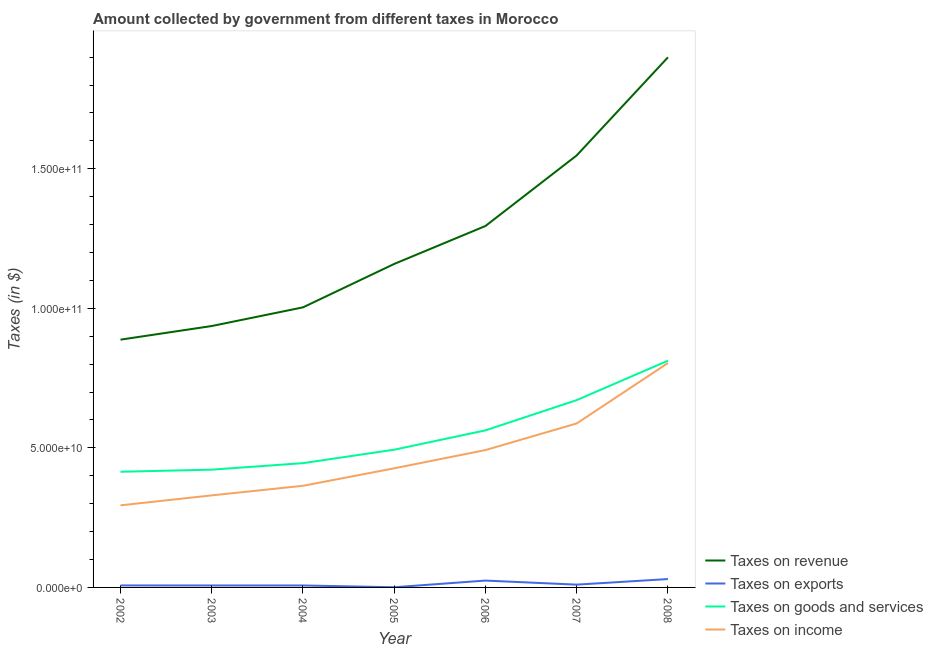Does the line corresponding to amount collected as tax on income intersect with the line corresponding to amount collected as tax on goods?
Keep it short and to the point. No. What is the amount collected as tax on revenue in 2007?
Ensure brevity in your answer.  1.55e+11. Across all years, what is the maximum amount collected as tax on goods?
Give a very brief answer. 8.12e+1. Across all years, what is the minimum amount collected as tax on income?
Offer a very short reply. 2.94e+1. What is the total amount collected as tax on goods in the graph?
Offer a terse response. 3.82e+11. What is the difference between the amount collected as tax on income in 2004 and that in 2007?
Provide a short and direct response. -2.23e+1. What is the difference between the amount collected as tax on income in 2002 and the amount collected as tax on exports in 2007?
Provide a succinct answer. 2.84e+1. What is the average amount collected as tax on goods per year?
Keep it short and to the point. 5.46e+1. In the year 2007, what is the difference between the amount collected as tax on exports and amount collected as tax on goods?
Keep it short and to the point. -6.61e+1. In how many years, is the amount collected as tax on revenue greater than 90000000000 $?
Offer a terse response. 6. What is the ratio of the amount collected as tax on income in 2003 to that in 2006?
Your answer should be very brief. 0.67. Is the amount collected as tax on revenue in 2005 less than that in 2008?
Keep it short and to the point. Yes. What is the difference between the highest and the second highest amount collected as tax on revenue?
Your answer should be very brief. 3.51e+1. What is the difference between the highest and the lowest amount collected as tax on exports?
Your answer should be very brief. 2.94e+09. In how many years, is the amount collected as tax on income greater than the average amount collected as tax on income taken over all years?
Offer a terse response. 3. Is it the case that in every year, the sum of the amount collected as tax on revenue and amount collected as tax on exports is greater than the amount collected as tax on goods?
Keep it short and to the point. Yes. Does the amount collected as tax on revenue monotonically increase over the years?
Offer a terse response. Yes. Is the amount collected as tax on exports strictly greater than the amount collected as tax on goods over the years?
Offer a terse response. No. How many years are there in the graph?
Keep it short and to the point. 7. Does the graph contain any zero values?
Keep it short and to the point. No. Does the graph contain grids?
Keep it short and to the point. No. Where does the legend appear in the graph?
Offer a very short reply. Bottom right. How many legend labels are there?
Ensure brevity in your answer.  4. What is the title of the graph?
Provide a short and direct response. Amount collected by government from different taxes in Morocco. What is the label or title of the X-axis?
Give a very brief answer. Year. What is the label or title of the Y-axis?
Provide a short and direct response. Taxes (in $). What is the Taxes (in $) in Taxes on revenue in 2002?
Your answer should be compact. 8.88e+1. What is the Taxes (in $) in Taxes on exports in 2002?
Provide a succinct answer. 7.10e+08. What is the Taxes (in $) of Taxes on goods and services in 2002?
Provide a short and direct response. 4.14e+1. What is the Taxes (in $) of Taxes on income in 2002?
Provide a short and direct response. 2.94e+1. What is the Taxes (in $) of Taxes on revenue in 2003?
Your answer should be compact. 9.37e+1. What is the Taxes (in $) of Taxes on exports in 2003?
Your response must be concise. 7.01e+08. What is the Taxes (in $) in Taxes on goods and services in 2003?
Your answer should be compact. 4.22e+1. What is the Taxes (in $) of Taxes on income in 2003?
Your response must be concise. 3.30e+1. What is the Taxes (in $) in Taxes on revenue in 2004?
Make the answer very short. 1.00e+11. What is the Taxes (in $) in Taxes on exports in 2004?
Your answer should be compact. 7.01e+08. What is the Taxes (in $) of Taxes on goods and services in 2004?
Your response must be concise. 4.45e+1. What is the Taxes (in $) of Taxes on income in 2004?
Keep it short and to the point. 3.64e+1. What is the Taxes (in $) of Taxes on revenue in 2005?
Your answer should be compact. 1.16e+11. What is the Taxes (in $) in Taxes on exports in 2005?
Your response must be concise. 6.21e+07. What is the Taxes (in $) in Taxes on goods and services in 2005?
Your answer should be very brief. 4.94e+1. What is the Taxes (in $) of Taxes on income in 2005?
Make the answer very short. 4.27e+1. What is the Taxes (in $) of Taxes on revenue in 2006?
Provide a succinct answer. 1.30e+11. What is the Taxes (in $) in Taxes on exports in 2006?
Ensure brevity in your answer.  2.46e+09. What is the Taxes (in $) of Taxes on goods and services in 2006?
Your answer should be compact. 5.63e+1. What is the Taxes (in $) of Taxes on income in 2006?
Keep it short and to the point. 4.92e+1. What is the Taxes (in $) of Taxes on revenue in 2007?
Provide a short and direct response. 1.55e+11. What is the Taxes (in $) of Taxes on goods and services in 2007?
Provide a succinct answer. 6.71e+1. What is the Taxes (in $) of Taxes on income in 2007?
Offer a terse response. 5.88e+1. What is the Taxes (in $) of Taxes on revenue in 2008?
Your answer should be very brief. 1.90e+11. What is the Taxes (in $) in Taxes on exports in 2008?
Provide a short and direct response. 3.00e+09. What is the Taxes (in $) of Taxes on goods and services in 2008?
Offer a very short reply. 8.12e+1. What is the Taxes (in $) of Taxes on income in 2008?
Your response must be concise. 8.04e+1. Across all years, what is the maximum Taxes (in $) of Taxes on revenue?
Give a very brief answer. 1.90e+11. Across all years, what is the maximum Taxes (in $) in Taxes on exports?
Make the answer very short. 3.00e+09. Across all years, what is the maximum Taxes (in $) of Taxes on goods and services?
Your response must be concise. 8.12e+1. Across all years, what is the maximum Taxes (in $) of Taxes on income?
Your response must be concise. 8.04e+1. Across all years, what is the minimum Taxes (in $) in Taxes on revenue?
Provide a succinct answer. 8.88e+1. Across all years, what is the minimum Taxes (in $) in Taxes on exports?
Offer a terse response. 6.21e+07. Across all years, what is the minimum Taxes (in $) in Taxes on goods and services?
Keep it short and to the point. 4.14e+1. Across all years, what is the minimum Taxes (in $) in Taxes on income?
Offer a terse response. 2.94e+1. What is the total Taxes (in $) in Taxes on revenue in the graph?
Provide a short and direct response. 8.73e+11. What is the total Taxes (in $) in Taxes on exports in the graph?
Provide a succinct answer. 8.63e+09. What is the total Taxes (in $) in Taxes on goods and services in the graph?
Ensure brevity in your answer.  3.82e+11. What is the total Taxes (in $) in Taxes on income in the graph?
Provide a short and direct response. 3.30e+11. What is the difference between the Taxes (in $) of Taxes on revenue in 2002 and that in 2003?
Provide a succinct answer. -4.88e+09. What is the difference between the Taxes (in $) in Taxes on exports in 2002 and that in 2003?
Your answer should be compact. 8.82e+06. What is the difference between the Taxes (in $) in Taxes on goods and services in 2002 and that in 2003?
Provide a succinct answer. -7.59e+08. What is the difference between the Taxes (in $) in Taxes on income in 2002 and that in 2003?
Offer a very short reply. -3.57e+09. What is the difference between the Taxes (in $) in Taxes on revenue in 2002 and that in 2004?
Offer a very short reply. -1.16e+1. What is the difference between the Taxes (in $) in Taxes on exports in 2002 and that in 2004?
Keep it short and to the point. 8.41e+06. What is the difference between the Taxes (in $) in Taxes on goods and services in 2002 and that in 2004?
Provide a short and direct response. -3.09e+09. What is the difference between the Taxes (in $) of Taxes on income in 2002 and that in 2004?
Make the answer very short. -7.00e+09. What is the difference between the Taxes (in $) in Taxes on revenue in 2002 and that in 2005?
Your answer should be very brief. -2.71e+1. What is the difference between the Taxes (in $) in Taxes on exports in 2002 and that in 2005?
Make the answer very short. 6.48e+08. What is the difference between the Taxes (in $) of Taxes on goods and services in 2002 and that in 2005?
Keep it short and to the point. -7.91e+09. What is the difference between the Taxes (in $) of Taxes on income in 2002 and that in 2005?
Give a very brief answer. -1.33e+1. What is the difference between the Taxes (in $) of Taxes on revenue in 2002 and that in 2006?
Provide a short and direct response. -4.07e+1. What is the difference between the Taxes (in $) of Taxes on exports in 2002 and that in 2006?
Make the answer very short. -1.75e+09. What is the difference between the Taxes (in $) in Taxes on goods and services in 2002 and that in 2006?
Your answer should be compact. -1.48e+1. What is the difference between the Taxes (in $) in Taxes on income in 2002 and that in 2006?
Make the answer very short. -1.98e+1. What is the difference between the Taxes (in $) in Taxes on revenue in 2002 and that in 2007?
Give a very brief answer. -6.60e+1. What is the difference between the Taxes (in $) of Taxes on exports in 2002 and that in 2007?
Provide a short and direct response. -2.90e+08. What is the difference between the Taxes (in $) of Taxes on goods and services in 2002 and that in 2007?
Your response must be concise. -2.57e+1. What is the difference between the Taxes (in $) in Taxes on income in 2002 and that in 2007?
Ensure brevity in your answer.  -2.93e+1. What is the difference between the Taxes (in $) of Taxes on revenue in 2002 and that in 2008?
Provide a succinct answer. -1.01e+11. What is the difference between the Taxes (in $) of Taxes on exports in 2002 and that in 2008?
Provide a succinct answer. -2.29e+09. What is the difference between the Taxes (in $) in Taxes on goods and services in 2002 and that in 2008?
Provide a short and direct response. -3.98e+1. What is the difference between the Taxes (in $) in Taxes on income in 2002 and that in 2008?
Give a very brief answer. -5.10e+1. What is the difference between the Taxes (in $) of Taxes on revenue in 2003 and that in 2004?
Ensure brevity in your answer.  -6.69e+09. What is the difference between the Taxes (in $) in Taxes on exports in 2003 and that in 2004?
Offer a terse response. -4.10e+05. What is the difference between the Taxes (in $) in Taxes on goods and services in 2003 and that in 2004?
Your response must be concise. -2.33e+09. What is the difference between the Taxes (in $) in Taxes on income in 2003 and that in 2004?
Provide a short and direct response. -3.43e+09. What is the difference between the Taxes (in $) of Taxes on revenue in 2003 and that in 2005?
Provide a short and direct response. -2.22e+1. What is the difference between the Taxes (in $) of Taxes on exports in 2003 and that in 2005?
Offer a terse response. 6.39e+08. What is the difference between the Taxes (in $) in Taxes on goods and services in 2003 and that in 2005?
Provide a succinct answer. -7.15e+09. What is the difference between the Taxes (in $) of Taxes on income in 2003 and that in 2005?
Make the answer very short. -9.70e+09. What is the difference between the Taxes (in $) of Taxes on revenue in 2003 and that in 2006?
Offer a very short reply. -3.58e+1. What is the difference between the Taxes (in $) in Taxes on exports in 2003 and that in 2006?
Your answer should be compact. -1.75e+09. What is the difference between the Taxes (in $) of Taxes on goods and services in 2003 and that in 2006?
Keep it short and to the point. -1.41e+1. What is the difference between the Taxes (in $) of Taxes on income in 2003 and that in 2006?
Keep it short and to the point. -1.62e+1. What is the difference between the Taxes (in $) in Taxes on revenue in 2003 and that in 2007?
Offer a terse response. -6.11e+1. What is the difference between the Taxes (in $) of Taxes on exports in 2003 and that in 2007?
Your answer should be compact. -2.99e+08. What is the difference between the Taxes (in $) in Taxes on goods and services in 2003 and that in 2007?
Your answer should be very brief. -2.49e+1. What is the difference between the Taxes (in $) of Taxes on income in 2003 and that in 2007?
Your answer should be compact. -2.58e+1. What is the difference between the Taxes (in $) of Taxes on revenue in 2003 and that in 2008?
Keep it short and to the point. -9.63e+1. What is the difference between the Taxes (in $) of Taxes on exports in 2003 and that in 2008?
Your answer should be very brief. -2.30e+09. What is the difference between the Taxes (in $) in Taxes on goods and services in 2003 and that in 2008?
Offer a terse response. -3.90e+1. What is the difference between the Taxes (in $) in Taxes on income in 2003 and that in 2008?
Your answer should be compact. -4.74e+1. What is the difference between the Taxes (in $) of Taxes on revenue in 2004 and that in 2005?
Your response must be concise. -1.56e+1. What is the difference between the Taxes (in $) of Taxes on exports in 2004 and that in 2005?
Give a very brief answer. 6.39e+08. What is the difference between the Taxes (in $) in Taxes on goods and services in 2004 and that in 2005?
Provide a succinct answer. -4.82e+09. What is the difference between the Taxes (in $) of Taxes on income in 2004 and that in 2005?
Give a very brief answer. -6.27e+09. What is the difference between the Taxes (in $) of Taxes on revenue in 2004 and that in 2006?
Give a very brief answer. -2.92e+1. What is the difference between the Taxes (in $) of Taxes on exports in 2004 and that in 2006?
Give a very brief answer. -1.75e+09. What is the difference between the Taxes (in $) of Taxes on goods and services in 2004 and that in 2006?
Ensure brevity in your answer.  -1.17e+1. What is the difference between the Taxes (in $) in Taxes on income in 2004 and that in 2006?
Provide a short and direct response. -1.28e+1. What is the difference between the Taxes (in $) in Taxes on revenue in 2004 and that in 2007?
Your response must be concise. -5.44e+1. What is the difference between the Taxes (in $) in Taxes on exports in 2004 and that in 2007?
Keep it short and to the point. -2.99e+08. What is the difference between the Taxes (in $) of Taxes on goods and services in 2004 and that in 2007?
Give a very brief answer. -2.26e+1. What is the difference between the Taxes (in $) of Taxes on income in 2004 and that in 2007?
Give a very brief answer. -2.23e+1. What is the difference between the Taxes (in $) in Taxes on revenue in 2004 and that in 2008?
Your answer should be very brief. -8.96e+1. What is the difference between the Taxes (in $) in Taxes on exports in 2004 and that in 2008?
Ensure brevity in your answer.  -2.30e+09. What is the difference between the Taxes (in $) in Taxes on goods and services in 2004 and that in 2008?
Make the answer very short. -3.67e+1. What is the difference between the Taxes (in $) in Taxes on income in 2004 and that in 2008?
Your response must be concise. -4.40e+1. What is the difference between the Taxes (in $) in Taxes on revenue in 2005 and that in 2006?
Ensure brevity in your answer.  -1.36e+1. What is the difference between the Taxes (in $) in Taxes on exports in 2005 and that in 2006?
Provide a short and direct response. -2.39e+09. What is the difference between the Taxes (in $) in Taxes on goods and services in 2005 and that in 2006?
Offer a terse response. -6.93e+09. What is the difference between the Taxes (in $) of Taxes on income in 2005 and that in 2006?
Ensure brevity in your answer.  -6.53e+09. What is the difference between the Taxes (in $) of Taxes on revenue in 2005 and that in 2007?
Make the answer very short. -3.89e+1. What is the difference between the Taxes (in $) in Taxes on exports in 2005 and that in 2007?
Provide a short and direct response. -9.38e+08. What is the difference between the Taxes (in $) in Taxes on goods and services in 2005 and that in 2007?
Your answer should be very brief. -1.78e+1. What is the difference between the Taxes (in $) in Taxes on income in 2005 and that in 2007?
Provide a short and direct response. -1.61e+1. What is the difference between the Taxes (in $) of Taxes on revenue in 2005 and that in 2008?
Your answer should be very brief. -7.40e+1. What is the difference between the Taxes (in $) of Taxes on exports in 2005 and that in 2008?
Offer a terse response. -2.94e+09. What is the difference between the Taxes (in $) in Taxes on goods and services in 2005 and that in 2008?
Offer a very short reply. -3.19e+1. What is the difference between the Taxes (in $) of Taxes on income in 2005 and that in 2008?
Your answer should be very brief. -3.77e+1. What is the difference between the Taxes (in $) in Taxes on revenue in 2006 and that in 2007?
Keep it short and to the point. -2.53e+1. What is the difference between the Taxes (in $) in Taxes on exports in 2006 and that in 2007?
Give a very brief answer. 1.46e+09. What is the difference between the Taxes (in $) in Taxes on goods and services in 2006 and that in 2007?
Offer a terse response. -1.08e+1. What is the difference between the Taxes (in $) of Taxes on income in 2006 and that in 2007?
Give a very brief answer. -9.54e+09. What is the difference between the Taxes (in $) of Taxes on revenue in 2006 and that in 2008?
Your response must be concise. -6.04e+1. What is the difference between the Taxes (in $) in Taxes on exports in 2006 and that in 2008?
Your response must be concise. -5.44e+08. What is the difference between the Taxes (in $) in Taxes on goods and services in 2006 and that in 2008?
Offer a terse response. -2.50e+1. What is the difference between the Taxes (in $) in Taxes on income in 2006 and that in 2008?
Provide a succinct answer. -3.12e+1. What is the difference between the Taxes (in $) of Taxes on revenue in 2007 and that in 2008?
Your answer should be compact. -3.51e+1. What is the difference between the Taxes (in $) of Taxes on exports in 2007 and that in 2008?
Your answer should be compact. -2.00e+09. What is the difference between the Taxes (in $) of Taxes on goods and services in 2007 and that in 2008?
Provide a short and direct response. -1.41e+1. What is the difference between the Taxes (in $) in Taxes on income in 2007 and that in 2008?
Give a very brief answer. -2.17e+1. What is the difference between the Taxes (in $) in Taxes on revenue in 2002 and the Taxes (in $) in Taxes on exports in 2003?
Give a very brief answer. 8.81e+1. What is the difference between the Taxes (in $) of Taxes on revenue in 2002 and the Taxes (in $) of Taxes on goods and services in 2003?
Offer a very short reply. 4.66e+1. What is the difference between the Taxes (in $) in Taxes on revenue in 2002 and the Taxes (in $) in Taxes on income in 2003?
Make the answer very short. 5.58e+1. What is the difference between the Taxes (in $) of Taxes on exports in 2002 and the Taxes (in $) of Taxes on goods and services in 2003?
Your answer should be compact. -4.15e+1. What is the difference between the Taxes (in $) in Taxes on exports in 2002 and the Taxes (in $) in Taxes on income in 2003?
Give a very brief answer. -3.23e+1. What is the difference between the Taxes (in $) of Taxes on goods and services in 2002 and the Taxes (in $) of Taxes on income in 2003?
Keep it short and to the point. 8.45e+09. What is the difference between the Taxes (in $) in Taxes on revenue in 2002 and the Taxes (in $) in Taxes on exports in 2004?
Your response must be concise. 8.81e+1. What is the difference between the Taxes (in $) of Taxes on revenue in 2002 and the Taxes (in $) of Taxes on goods and services in 2004?
Offer a terse response. 4.43e+1. What is the difference between the Taxes (in $) of Taxes on revenue in 2002 and the Taxes (in $) of Taxes on income in 2004?
Your response must be concise. 5.24e+1. What is the difference between the Taxes (in $) of Taxes on exports in 2002 and the Taxes (in $) of Taxes on goods and services in 2004?
Make the answer very short. -4.38e+1. What is the difference between the Taxes (in $) of Taxes on exports in 2002 and the Taxes (in $) of Taxes on income in 2004?
Your answer should be compact. -3.57e+1. What is the difference between the Taxes (in $) in Taxes on goods and services in 2002 and the Taxes (in $) in Taxes on income in 2004?
Your answer should be compact. 5.02e+09. What is the difference between the Taxes (in $) in Taxes on revenue in 2002 and the Taxes (in $) in Taxes on exports in 2005?
Give a very brief answer. 8.87e+1. What is the difference between the Taxes (in $) in Taxes on revenue in 2002 and the Taxes (in $) in Taxes on goods and services in 2005?
Keep it short and to the point. 3.94e+1. What is the difference between the Taxes (in $) in Taxes on revenue in 2002 and the Taxes (in $) in Taxes on income in 2005?
Your response must be concise. 4.61e+1. What is the difference between the Taxes (in $) in Taxes on exports in 2002 and the Taxes (in $) in Taxes on goods and services in 2005?
Offer a very short reply. -4.86e+1. What is the difference between the Taxes (in $) of Taxes on exports in 2002 and the Taxes (in $) of Taxes on income in 2005?
Offer a terse response. -4.20e+1. What is the difference between the Taxes (in $) of Taxes on goods and services in 2002 and the Taxes (in $) of Taxes on income in 2005?
Your answer should be compact. -1.24e+09. What is the difference between the Taxes (in $) in Taxes on revenue in 2002 and the Taxes (in $) in Taxes on exports in 2006?
Your response must be concise. 8.63e+1. What is the difference between the Taxes (in $) in Taxes on revenue in 2002 and the Taxes (in $) in Taxes on goods and services in 2006?
Give a very brief answer. 3.25e+1. What is the difference between the Taxes (in $) of Taxes on revenue in 2002 and the Taxes (in $) of Taxes on income in 2006?
Offer a very short reply. 3.96e+1. What is the difference between the Taxes (in $) in Taxes on exports in 2002 and the Taxes (in $) in Taxes on goods and services in 2006?
Keep it short and to the point. -5.56e+1. What is the difference between the Taxes (in $) of Taxes on exports in 2002 and the Taxes (in $) of Taxes on income in 2006?
Offer a terse response. -4.85e+1. What is the difference between the Taxes (in $) in Taxes on goods and services in 2002 and the Taxes (in $) in Taxes on income in 2006?
Your answer should be very brief. -7.78e+09. What is the difference between the Taxes (in $) of Taxes on revenue in 2002 and the Taxes (in $) of Taxes on exports in 2007?
Your answer should be compact. 8.78e+1. What is the difference between the Taxes (in $) of Taxes on revenue in 2002 and the Taxes (in $) of Taxes on goods and services in 2007?
Provide a short and direct response. 2.17e+1. What is the difference between the Taxes (in $) in Taxes on revenue in 2002 and the Taxes (in $) in Taxes on income in 2007?
Offer a terse response. 3.00e+1. What is the difference between the Taxes (in $) in Taxes on exports in 2002 and the Taxes (in $) in Taxes on goods and services in 2007?
Offer a terse response. -6.64e+1. What is the difference between the Taxes (in $) of Taxes on exports in 2002 and the Taxes (in $) of Taxes on income in 2007?
Make the answer very short. -5.80e+1. What is the difference between the Taxes (in $) of Taxes on goods and services in 2002 and the Taxes (in $) of Taxes on income in 2007?
Offer a terse response. -1.73e+1. What is the difference between the Taxes (in $) of Taxes on revenue in 2002 and the Taxes (in $) of Taxes on exports in 2008?
Your answer should be very brief. 8.58e+1. What is the difference between the Taxes (in $) of Taxes on revenue in 2002 and the Taxes (in $) of Taxes on goods and services in 2008?
Offer a very short reply. 7.54e+09. What is the difference between the Taxes (in $) of Taxes on revenue in 2002 and the Taxes (in $) of Taxes on income in 2008?
Your answer should be very brief. 8.38e+09. What is the difference between the Taxes (in $) in Taxes on exports in 2002 and the Taxes (in $) in Taxes on goods and services in 2008?
Provide a short and direct response. -8.05e+1. What is the difference between the Taxes (in $) in Taxes on exports in 2002 and the Taxes (in $) in Taxes on income in 2008?
Ensure brevity in your answer.  -7.97e+1. What is the difference between the Taxes (in $) in Taxes on goods and services in 2002 and the Taxes (in $) in Taxes on income in 2008?
Give a very brief answer. -3.90e+1. What is the difference between the Taxes (in $) of Taxes on revenue in 2003 and the Taxes (in $) of Taxes on exports in 2004?
Offer a terse response. 9.30e+1. What is the difference between the Taxes (in $) in Taxes on revenue in 2003 and the Taxes (in $) in Taxes on goods and services in 2004?
Ensure brevity in your answer.  4.91e+1. What is the difference between the Taxes (in $) in Taxes on revenue in 2003 and the Taxes (in $) in Taxes on income in 2004?
Provide a succinct answer. 5.72e+1. What is the difference between the Taxes (in $) in Taxes on exports in 2003 and the Taxes (in $) in Taxes on goods and services in 2004?
Ensure brevity in your answer.  -4.38e+1. What is the difference between the Taxes (in $) in Taxes on exports in 2003 and the Taxes (in $) in Taxes on income in 2004?
Offer a terse response. -3.57e+1. What is the difference between the Taxes (in $) of Taxes on goods and services in 2003 and the Taxes (in $) of Taxes on income in 2004?
Keep it short and to the point. 5.78e+09. What is the difference between the Taxes (in $) in Taxes on revenue in 2003 and the Taxes (in $) in Taxes on exports in 2005?
Offer a very short reply. 9.36e+1. What is the difference between the Taxes (in $) in Taxes on revenue in 2003 and the Taxes (in $) in Taxes on goods and services in 2005?
Offer a terse response. 4.43e+1. What is the difference between the Taxes (in $) in Taxes on revenue in 2003 and the Taxes (in $) in Taxes on income in 2005?
Keep it short and to the point. 5.10e+1. What is the difference between the Taxes (in $) of Taxes on exports in 2003 and the Taxes (in $) of Taxes on goods and services in 2005?
Give a very brief answer. -4.86e+1. What is the difference between the Taxes (in $) in Taxes on exports in 2003 and the Taxes (in $) in Taxes on income in 2005?
Make the answer very short. -4.20e+1. What is the difference between the Taxes (in $) of Taxes on goods and services in 2003 and the Taxes (in $) of Taxes on income in 2005?
Your answer should be compact. -4.86e+08. What is the difference between the Taxes (in $) of Taxes on revenue in 2003 and the Taxes (in $) of Taxes on exports in 2006?
Provide a succinct answer. 9.12e+1. What is the difference between the Taxes (in $) of Taxes on revenue in 2003 and the Taxes (in $) of Taxes on goods and services in 2006?
Provide a short and direct response. 3.74e+1. What is the difference between the Taxes (in $) of Taxes on revenue in 2003 and the Taxes (in $) of Taxes on income in 2006?
Your answer should be compact. 4.44e+1. What is the difference between the Taxes (in $) of Taxes on exports in 2003 and the Taxes (in $) of Taxes on goods and services in 2006?
Keep it short and to the point. -5.56e+1. What is the difference between the Taxes (in $) of Taxes on exports in 2003 and the Taxes (in $) of Taxes on income in 2006?
Give a very brief answer. -4.85e+1. What is the difference between the Taxes (in $) of Taxes on goods and services in 2003 and the Taxes (in $) of Taxes on income in 2006?
Ensure brevity in your answer.  -7.02e+09. What is the difference between the Taxes (in $) of Taxes on revenue in 2003 and the Taxes (in $) of Taxes on exports in 2007?
Offer a very short reply. 9.27e+1. What is the difference between the Taxes (in $) of Taxes on revenue in 2003 and the Taxes (in $) of Taxes on goods and services in 2007?
Keep it short and to the point. 2.65e+1. What is the difference between the Taxes (in $) of Taxes on revenue in 2003 and the Taxes (in $) of Taxes on income in 2007?
Your response must be concise. 3.49e+1. What is the difference between the Taxes (in $) of Taxes on exports in 2003 and the Taxes (in $) of Taxes on goods and services in 2007?
Keep it short and to the point. -6.64e+1. What is the difference between the Taxes (in $) in Taxes on exports in 2003 and the Taxes (in $) in Taxes on income in 2007?
Ensure brevity in your answer.  -5.81e+1. What is the difference between the Taxes (in $) in Taxes on goods and services in 2003 and the Taxes (in $) in Taxes on income in 2007?
Offer a terse response. -1.66e+1. What is the difference between the Taxes (in $) in Taxes on revenue in 2003 and the Taxes (in $) in Taxes on exports in 2008?
Make the answer very short. 9.07e+1. What is the difference between the Taxes (in $) in Taxes on revenue in 2003 and the Taxes (in $) in Taxes on goods and services in 2008?
Your response must be concise. 1.24e+1. What is the difference between the Taxes (in $) of Taxes on revenue in 2003 and the Taxes (in $) of Taxes on income in 2008?
Give a very brief answer. 1.33e+1. What is the difference between the Taxes (in $) of Taxes on exports in 2003 and the Taxes (in $) of Taxes on goods and services in 2008?
Your answer should be very brief. -8.05e+1. What is the difference between the Taxes (in $) in Taxes on exports in 2003 and the Taxes (in $) in Taxes on income in 2008?
Ensure brevity in your answer.  -7.97e+1. What is the difference between the Taxes (in $) of Taxes on goods and services in 2003 and the Taxes (in $) of Taxes on income in 2008?
Ensure brevity in your answer.  -3.82e+1. What is the difference between the Taxes (in $) of Taxes on revenue in 2004 and the Taxes (in $) of Taxes on exports in 2005?
Offer a terse response. 1.00e+11. What is the difference between the Taxes (in $) in Taxes on revenue in 2004 and the Taxes (in $) in Taxes on goods and services in 2005?
Make the answer very short. 5.10e+1. What is the difference between the Taxes (in $) of Taxes on revenue in 2004 and the Taxes (in $) of Taxes on income in 2005?
Ensure brevity in your answer.  5.77e+1. What is the difference between the Taxes (in $) of Taxes on exports in 2004 and the Taxes (in $) of Taxes on goods and services in 2005?
Offer a terse response. -4.86e+1. What is the difference between the Taxes (in $) in Taxes on exports in 2004 and the Taxes (in $) in Taxes on income in 2005?
Ensure brevity in your answer.  -4.20e+1. What is the difference between the Taxes (in $) in Taxes on goods and services in 2004 and the Taxes (in $) in Taxes on income in 2005?
Offer a terse response. 1.85e+09. What is the difference between the Taxes (in $) of Taxes on revenue in 2004 and the Taxes (in $) of Taxes on exports in 2006?
Make the answer very short. 9.79e+1. What is the difference between the Taxes (in $) of Taxes on revenue in 2004 and the Taxes (in $) of Taxes on goods and services in 2006?
Keep it short and to the point. 4.41e+1. What is the difference between the Taxes (in $) in Taxes on revenue in 2004 and the Taxes (in $) in Taxes on income in 2006?
Offer a terse response. 5.11e+1. What is the difference between the Taxes (in $) in Taxes on exports in 2004 and the Taxes (in $) in Taxes on goods and services in 2006?
Offer a terse response. -5.56e+1. What is the difference between the Taxes (in $) of Taxes on exports in 2004 and the Taxes (in $) of Taxes on income in 2006?
Keep it short and to the point. -4.85e+1. What is the difference between the Taxes (in $) in Taxes on goods and services in 2004 and the Taxes (in $) in Taxes on income in 2006?
Keep it short and to the point. -4.68e+09. What is the difference between the Taxes (in $) of Taxes on revenue in 2004 and the Taxes (in $) of Taxes on exports in 2007?
Offer a very short reply. 9.94e+1. What is the difference between the Taxes (in $) of Taxes on revenue in 2004 and the Taxes (in $) of Taxes on goods and services in 2007?
Your answer should be compact. 3.32e+1. What is the difference between the Taxes (in $) of Taxes on revenue in 2004 and the Taxes (in $) of Taxes on income in 2007?
Provide a short and direct response. 4.16e+1. What is the difference between the Taxes (in $) in Taxes on exports in 2004 and the Taxes (in $) in Taxes on goods and services in 2007?
Your response must be concise. -6.64e+1. What is the difference between the Taxes (in $) of Taxes on exports in 2004 and the Taxes (in $) of Taxes on income in 2007?
Give a very brief answer. -5.81e+1. What is the difference between the Taxes (in $) in Taxes on goods and services in 2004 and the Taxes (in $) in Taxes on income in 2007?
Offer a very short reply. -1.42e+1. What is the difference between the Taxes (in $) of Taxes on revenue in 2004 and the Taxes (in $) of Taxes on exports in 2008?
Provide a short and direct response. 9.74e+1. What is the difference between the Taxes (in $) in Taxes on revenue in 2004 and the Taxes (in $) in Taxes on goods and services in 2008?
Give a very brief answer. 1.91e+1. What is the difference between the Taxes (in $) in Taxes on revenue in 2004 and the Taxes (in $) in Taxes on income in 2008?
Provide a succinct answer. 1.99e+1. What is the difference between the Taxes (in $) in Taxes on exports in 2004 and the Taxes (in $) in Taxes on goods and services in 2008?
Offer a terse response. -8.05e+1. What is the difference between the Taxes (in $) of Taxes on exports in 2004 and the Taxes (in $) of Taxes on income in 2008?
Your answer should be very brief. -7.97e+1. What is the difference between the Taxes (in $) of Taxes on goods and services in 2004 and the Taxes (in $) of Taxes on income in 2008?
Make the answer very short. -3.59e+1. What is the difference between the Taxes (in $) in Taxes on revenue in 2005 and the Taxes (in $) in Taxes on exports in 2006?
Your answer should be very brief. 1.13e+11. What is the difference between the Taxes (in $) in Taxes on revenue in 2005 and the Taxes (in $) in Taxes on goods and services in 2006?
Provide a succinct answer. 5.96e+1. What is the difference between the Taxes (in $) of Taxes on revenue in 2005 and the Taxes (in $) of Taxes on income in 2006?
Provide a short and direct response. 6.67e+1. What is the difference between the Taxes (in $) in Taxes on exports in 2005 and the Taxes (in $) in Taxes on goods and services in 2006?
Keep it short and to the point. -5.62e+1. What is the difference between the Taxes (in $) of Taxes on exports in 2005 and the Taxes (in $) of Taxes on income in 2006?
Ensure brevity in your answer.  -4.92e+1. What is the difference between the Taxes (in $) in Taxes on goods and services in 2005 and the Taxes (in $) in Taxes on income in 2006?
Your answer should be very brief. 1.36e+08. What is the difference between the Taxes (in $) in Taxes on revenue in 2005 and the Taxes (in $) in Taxes on exports in 2007?
Give a very brief answer. 1.15e+11. What is the difference between the Taxes (in $) of Taxes on revenue in 2005 and the Taxes (in $) of Taxes on goods and services in 2007?
Give a very brief answer. 4.88e+1. What is the difference between the Taxes (in $) of Taxes on revenue in 2005 and the Taxes (in $) of Taxes on income in 2007?
Give a very brief answer. 5.72e+1. What is the difference between the Taxes (in $) of Taxes on exports in 2005 and the Taxes (in $) of Taxes on goods and services in 2007?
Offer a terse response. -6.71e+1. What is the difference between the Taxes (in $) in Taxes on exports in 2005 and the Taxes (in $) in Taxes on income in 2007?
Ensure brevity in your answer.  -5.87e+1. What is the difference between the Taxes (in $) in Taxes on goods and services in 2005 and the Taxes (in $) in Taxes on income in 2007?
Ensure brevity in your answer.  -9.40e+09. What is the difference between the Taxes (in $) of Taxes on revenue in 2005 and the Taxes (in $) of Taxes on exports in 2008?
Offer a very short reply. 1.13e+11. What is the difference between the Taxes (in $) of Taxes on revenue in 2005 and the Taxes (in $) of Taxes on goods and services in 2008?
Your response must be concise. 3.47e+1. What is the difference between the Taxes (in $) of Taxes on revenue in 2005 and the Taxes (in $) of Taxes on income in 2008?
Keep it short and to the point. 3.55e+1. What is the difference between the Taxes (in $) of Taxes on exports in 2005 and the Taxes (in $) of Taxes on goods and services in 2008?
Give a very brief answer. -8.12e+1. What is the difference between the Taxes (in $) in Taxes on exports in 2005 and the Taxes (in $) in Taxes on income in 2008?
Provide a short and direct response. -8.03e+1. What is the difference between the Taxes (in $) in Taxes on goods and services in 2005 and the Taxes (in $) in Taxes on income in 2008?
Provide a succinct answer. -3.11e+1. What is the difference between the Taxes (in $) of Taxes on revenue in 2006 and the Taxes (in $) of Taxes on exports in 2007?
Give a very brief answer. 1.29e+11. What is the difference between the Taxes (in $) of Taxes on revenue in 2006 and the Taxes (in $) of Taxes on goods and services in 2007?
Keep it short and to the point. 6.24e+1. What is the difference between the Taxes (in $) of Taxes on revenue in 2006 and the Taxes (in $) of Taxes on income in 2007?
Your answer should be compact. 7.08e+1. What is the difference between the Taxes (in $) of Taxes on exports in 2006 and the Taxes (in $) of Taxes on goods and services in 2007?
Ensure brevity in your answer.  -6.47e+1. What is the difference between the Taxes (in $) in Taxes on exports in 2006 and the Taxes (in $) in Taxes on income in 2007?
Make the answer very short. -5.63e+1. What is the difference between the Taxes (in $) of Taxes on goods and services in 2006 and the Taxes (in $) of Taxes on income in 2007?
Give a very brief answer. -2.47e+09. What is the difference between the Taxes (in $) in Taxes on revenue in 2006 and the Taxes (in $) in Taxes on exports in 2008?
Make the answer very short. 1.27e+11. What is the difference between the Taxes (in $) in Taxes on revenue in 2006 and the Taxes (in $) in Taxes on goods and services in 2008?
Give a very brief answer. 4.83e+1. What is the difference between the Taxes (in $) of Taxes on revenue in 2006 and the Taxes (in $) of Taxes on income in 2008?
Give a very brief answer. 4.91e+1. What is the difference between the Taxes (in $) of Taxes on exports in 2006 and the Taxes (in $) of Taxes on goods and services in 2008?
Give a very brief answer. -7.88e+1. What is the difference between the Taxes (in $) in Taxes on exports in 2006 and the Taxes (in $) in Taxes on income in 2008?
Provide a succinct answer. -7.80e+1. What is the difference between the Taxes (in $) of Taxes on goods and services in 2006 and the Taxes (in $) of Taxes on income in 2008?
Offer a very short reply. -2.41e+1. What is the difference between the Taxes (in $) in Taxes on revenue in 2007 and the Taxes (in $) in Taxes on exports in 2008?
Your answer should be compact. 1.52e+11. What is the difference between the Taxes (in $) of Taxes on revenue in 2007 and the Taxes (in $) of Taxes on goods and services in 2008?
Provide a short and direct response. 7.36e+1. What is the difference between the Taxes (in $) in Taxes on revenue in 2007 and the Taxes (in $) in Taxes on income in 2008?
Provide a succinct answer. 7.44e+1. What is the difference between the Taxes (in $) of Taxes on exports in 2007 and the Taxes (in $) of Taxes on goods and services in 2008?
Provide a short and direct response. -8.02e+1. What is the difference between the Taxes (in $) of Taxes on exports in 2007 and the Taxes (in $) of Taxes on income in 2008?
Offer a very short reply. -7.94e+1. What is the difference between the Taxes (in $) in Taxes on goods and services in 2007 and the Taxes (in $) in Taxes on income in 2008?
Offer a terse response. -1.33e+1. What is the average Taxes (in $) in Taxes on revenue per year?
Your answer should be compact. 1.25e+11. What is the average Taxes (in $) of Taxes on exports per year?
Keep it short and to the point. 1.23e+09. What is the average Taxes (in $) in Taxes on goods and services per year?
Your answer should be very brief. 5.46e+1. What is the average Taxes (in $) of Taxes on income per year?
Offer a very short reply. 4.71e+1. In the year 2002, what is the difference between the Taxes (in $) in Taxes on revenue and Taxes (in $) in Taxes on exports?
Ensure brevity in your answer.  8.81e+1. In the year 2002, what is the difference between the Taxes (in $) of Taxes on revenue and Taxes (in $) of Taxes on goods and services?
Provide a short and direct response. 4.73e+1. In the year 2002, what is the difference between the Taxes (in $) in Taxes on revenue and Taxes (in $) in Taxes on income?
Your response must be concise. 5.94e+1. In the year 2002, what is the difference between the Taxes (in $) of Taxes on exports and Taxes (in $) of Taxes on goods and services?
Your answer should be compact. -4.07e+1. In the year 2002, what is the difference between the Taxes (in $) of Taxes on exports and Taxes (in $) of Taxes on income?
Make the answer very short. -2.87e+1. In the year 2002, what is the difference between the Taxes (in $) in Taxes on goods and services and Taxes (in $) in Taxes on income?
Make the answer very short. 1.20e+1. In the year 2003, what is the difference between the Taxes (in $) in Taxes on revenue and Taxes (in $) in Taxes on exports?
Your answer should be very brief. 9.30e+1. In the year 2003, what is the difference between the Taxes (in $) of Taxes on revenue and Taxes (in $) of Taxes on goods and services?
Your answer should be very brief. 5.15e+1. In the year 2003, what is the difference between the Taxes (in $) of Taxes on revenue and Taxes (in $) of Taxes on income?
Provide a short and direct response. 6.07e+1. In the year 2003, what is the difference between the Taxes (in $) of Taxes on exports and Taxes (in $) of Taxes on goods and services?
Provide a succinct answer. -4.15e+1. In the year 2003, what is the difference between the Taxes (in $) of Taxes on exports and Taxes (in $) of Taxes on income?
Provide a succinct answer. -3.23e+1. In the year 2003, what is the difference between the Taxes (in $) in Taxes on goods and services and Taxes (in $) in Taxes on income?
Keep it short and to the point. 9.21e+09. In the year 2004, what is the difference between the Taxes (in $) in Taxes on revenue and Taxes (in $) in Taxes on exports?
Your answer should be very brief. 9.97e+1. In the year 2004, what is the difference between the Taxes (in $) in Taxes on revenue and Taxes (in $) in Taxes on goods and services?
Keep it short and to the point. 5.58e+1. In the year 2004, what is the difference between the Taxes (in $) of Taxes on revenue and Taxes (in $) of Taxes on income?
Provide a succinct answer. 6.39e+1. In the year 2004, what is the difference between the Taxes (in $) in Taxes on exports and Taxes (in $) in Taxes on goods and services?
Make the answer very short. -4.38e+1. In the year 2004, what is the difference between the Taxes (in $) in Taxes on exports and Taxes (in $) in Taxes on income?
Make the answer very short. -3.57e+1. In the year 2004, what is the difference between the Taxes (in $) of Taxes on goods and services and Taxes (in $) of Taxes on income?
Give a very brief answer. 8.12e+09. In the year 2005, what is the difference between the Taxes (in $) in Taxes on revenue and Taxes (in $) in Taxes on exports?
Provide a succinct answer. 1.16e+11. In the year 2005, what is the difference between the Taxes (in $) of Taxes on revenue and Taxes (in $) of Taxes on goods and services?
Make the answer very short. 6.66e+1. In the year 2005, what is the difference between the Taxes (in $) of Taxes on revenue and Taxes (in $) of Taxes on income?
Offer a terse response. 7.32e+1. In the year 2005, what is the difference between the Taxes (in $) in Taxes on exports and Taxes (in $) in Taxes on goods and services?
Give a very brief answer. -4.93e+1. In the year 2005, what is the difference between the Taxes (in $) in Taxes on exports and Taxes (in $) in Taxes on income?
Give a very brief answer. -4.26e+1. In the year 2005, what is the difference between the Taxes (in $) of Taxes on goods and services and Taxes (in $) of Taxes on income?
Your response must be concise. 6.67e+09. In the year 2006, what is the difference between the Taxes (in $) in Taxes on revenue and Taxes (in $) in Taxes on exports?
Offer a terse response. 1.27e+11. In the year 2006, what is the difference between the Taxes (in $) in Taxes on revenue and Taxes (in $) in Taxes on goods and services?
Give a very brief answer. 7.32e+1. In the year 2006, what is the difference between the Taxes (in $) of Taxes on revenue and Taxes (in $) of Taxes on income?
Your answer should be compact. 8.03e+1. In the year 2006, what is the difference between the Taxes (in $) in Taxes on exports and Taxes (in $) in Taxes on goods and services?
Give a very brief answer. -5.38e+1. In the year 2006, what is the difference between the Taxes (in $) of Taxes on exports and Taxes (in $) of Taxes on income?
Ensure brevity in your answer.  -4.68e+1. In the year 2006, what is the difference between the Taxes (in $) in Taxes on goods and services and Taxes (in $) in Taxes on income?
Provide a short and direct response. 7.06e+09. In the year 2007, what is the difference between the Taxes (in $) of Taxes on revenue and Taxes (in $) of Taxes on exports?
Keep it short and to the point. 1.54e+11. In the year 2007, what is the difference between the Taxes (in $) of Taxes on revenue and Taxes (in $) of Taxes on goods and services?
Offer a very short reply. 8.77e+1. In the year 2007, what is the difference between the Taxes (in $) in Taxes on revenue and Taxes (in $) in Taxes on income?
Your response must be concise. 9.60e+1. In the year 2007, what is the difference between the Taxes (in $) of Taxes on exports and Taxes (in $) of Taxes on goods and services?
Offer a very short reply. -6.61e+1. In the year 2007, what is the difference between the Taxes (in $) in Taxes on exports and Taxes (in $) in Taxes on income?
Provide a succinct answer. -5.78e+1. In the year 2007, what is the difference between the Taxes (in $) in Taxes on goods and services and Taxes (in $) in Taxes on income?
Your answer should be very brief. 8.36e+09. In the year 2008, what is the difference between the Taxes (in $) of Taxes on revenue and Taxes (in $) of Taxes on exports?
Your answer should be very brief. 1.87e+11. In the year 2008, what is the difference between the Taxes (in $) of Taxes on revenue and Taxes (in $) of Taxes on goods and services?
Keep it short and to the point. 1.09e+11. In the year 2008, what is the difference between the Taxes (in $) of Taxes on revenue and Taxes (in $) of Taxes on income?
Give a very brief answer. 1.10e+11. In the year 2008, what is the difference between the Taxes (in $) in Taxes on exports and Taxes (in $) in Taxes on goods and services?
Keep it short and to the point. -7.82e+1. In the year 2008, what is the difference between the Taxes (in $) in Taxes on exports and Taxes (in $) in Taxes on income?
Your answer should be compact. -7.74e+1. In the year 2008, what is the difference between the Taxes (in $) of Taxes on goods and services and Taxes (in $) of Taxes on income?
Offer a very short reply. 8.37e+08. What is the ratio of the Taxes (in $) in Taxes on revenue in 2002 to that in 2003?
Offer a terse response. 0.95. What is the ratio of the Taxes (in $) in Taxes on exports in 2002 to that in 2003?
Ensure brevity in your answer.  1.01. What is the ratio of the Taxes (in $) in Taxes on goods and services in 2002 to that in 2003?
Provide a short and direct response. 0.98. What is the ratio of the Taxes (in $) of Taxes on income in 2002 to that in 2003?
Your answer should be very brief. 0.89. What is the ratio of the Taxes (in $) in Taxes on revenue in 2002 to that in 2004?
Your answer should be compact. 0.88. What is the ratio of the Taxes (in $) of Taxes on exports in 2002 to that in 2004?
Offer a very short reply. 1.01. What is the ratio of the Taxes (in $) in Taxes on goods and services in 2002 to that in 2004?
Keep it short and to the point. 0.93. What is the ratio of the Taxes (in $) of Taxes on income in 2002 to that in 2004?
Provide a short and direct response. 0.81. What is the ratio of the Taxes (in $) of Taxes on revenue in 2002 to that in 2005?
Offer a very short reply. 0.77. What is the ratio of the Taxes (in $) of Taxes on exports in 2002 to that in 2005?
Your answer should be compact. 11.43. What is the ratio of the Taxes (in $) in Taxes on goods and services in 2002 to that in 2005?
Provide a short and direct response. 0.84. What is the ratio of the Taxes (in $) in Taxes on income in 2002 to that in 2005?
Your response must be concise. 0.69. What is the ratio of the Taxes (in $) of Taxes on revenue in 2002 to that in 2006?
Your answer should be compact. 0.69. What is the ratio of the Taxes (in $) in Taxes on exports in 2002 to that in 2006?
Your response must be concise. 0.29. What is the ratio of the Taxes (in $) of Taxes on goods and services in 2002 to that in 2006?
Keep it short and to the point. 0.74. What is the ratio of the Taxes (in $) in Taxes on income in 2002 to that in 2006?
Provide a short and direct response. 0.6. What is the ratio of the Taxes (in $) in Taxes on revenue in 2002 to that in 2007?
Provide a short and direct response. 0.57. What is the ratio of the Taxes (in $) of Taxes on exports in 2002 to that in 2007?
Provide a short and direct response. 0.71. What is the ratio of the Taxes (in $) in Taxes on goods and services in 2002 to that in 2007?
Ensure brevity in your answer.  0.62. What is the ratio of the Taxes (in $) in Taxes on income in 2002 to that in 2007?
Ensure brevity in your answer.  0.5. What is the ratio of the Taxes (in $) in Taxes on revenue in 2002 to that in 2008?
Provide a short and direct response. 0.47. What is the ratio of the Taxes (in $) in Taxes on exports in 2002 to that in 2008?
Provide a short and direct response. 0.24. What is the ratio of the Taxes (in $) of Taxes on goods and services in 2002 to that in 2008?
Provide a short and direct response. 0.51. What is the ratio of the Taxes (in $) of Taxes on income in 2002 to that in 2008?
Your response must be concise. 0.37. What is the ratio of the Taxes (in $) in Taxes on exports in 2003 to that in 2004?
Provide a short and direct response. 1. What is the ratio of the Taxes (in $) of Taxes on goods and services in 2003 to that in 2004?
Your answer should be very brief. 0.95. What is the ratio of the Taxes (in $) of Taxes on income in 2003 to that in 2004?
Offer a terse response. 0.91. What is the ratio of the Taxes (in $) in Taxes on revenue in 2003 to that in 2005?
Your answer should be compact. 0.81. What is the ratio of the Taxes (in $) in Taxes on exports in 2003 to that in 2005?
Offer a very short reply. 11.29. What is the ratio of the Taxes (in $) in Taxes on goods and services in 2003 to that in 2005?
Offer a terse response. 0.86. What is the ratio of the Taxes (in $) of Taxes on income in 2003 to that in 2005?
Make the answer very short. 0.77. What is the ratio of the Taxes (in $) of Taxes on revenue in 2003 to that in 2006?
Give a very brief answer. 0.72. What is the ratio of the Taxes (in $) of Taxes on exports in 2003 to that in 2006?
Offer a terse response. 0.29. What is the ratio of the Taxes (in $) of Taxes on goods and services in 2003 to that in 2006?
Offer a terse response. 0.75. What is the ratio of the Taxes (in $) in Taxes on income in 2003 to that in 2006?
Provide a succinct answer. 0.67. What is the ratio of the Taxes (in $) in Taxes on revenue in 2003 to that in 2007?
Offer a terse response. 0.61. What is the ratio of the Taxes (in $) of Taxes on exports in 2003 to that in 2007?
Give a very brief answer. 0.7. What is the ratio of the Taxes (in $) in Taxes on goods and services in 2003 to that in 2007?
Provide a succinct answer. 0.63. What is the ratio of the Taxes (in $) in Taxes on income in 2003 to that in 2007?
Offer a terse response. 0.56. What is the ratio of the Taxes (in $) in Taxes on revenue in 2003 to that in 2008?
Your answer should be compact. 0.49. What is the ratio of the Taxes (in $) in Taxes on exports in 2003 to that in 2008?
Ensure brevity in your answer.  0.23. What is the ratio of the Taxes (in $) in Taxes on goods and services in 2003 to that in 2008?
Your answer should be very brief. 0.52. What is the ratio of the Taxes (in $) of Taxes on income in 2003 to that in 2008?
Ensure brevity in your answer.  0.41. What is the ratio of the Taxes (in $) of Taxes on revenue in 2004 to that in 2005?
Ensure brevity in your answer.  0.87. What is the ratio of the Taxes (in $) in Taxes on exports in 2004 to that in 2005?
Your answer should be compact. 11.29. What is the ratio of the Taxes (in $) in Taxes on goods and services in 2004 to that in 2005?
Keep it short and to the point. 0.9. What is the ratio of the Taxes (in $) in Taxes on income in 2004 to that in 2005?
Make the answer very short. 0.85. What is the ratio of the Taxes (in $) of Taxes on revenue in 2004 to that in 2006?
Offer a terse response. 0.77. What is the ratio of the Taxes (in $) in Taxes on exports in 2004 to that in 2006?
Make the answer very short. 0.29. What is the ratio of the Taxes (in $) in Taxes on goods and services in 2004 to that in 2006?
Provide a short and direct response. 0.79. What is the ratio of the Taxes (in $) in Taxes on income in 2004 to that in 2006?
Your answer should be very brief. 0.74. What is the ratio of the Taxes (in $) in Taxes on revenue in 2004 to that in 2007?
Your answer should be compact. 0.65. What is the ratio of the Taxes (in $) in Taxes on exports in 2004 to that in 2007?
Make the answer very short. 0.7. What is the ratio of the Taxes (in $) in Taxes on goods and services in 2004 to that in 2007?
Your response must be concise. 0.66. What is the ratio of the Taxes (in $) of Taxes on income in 2004 to that in 2007?
Make the answer very short. 0.62. What is the ratio of the Taxes (in $) in Taxes on revenue in 2004 to that in 2008?
Offer a terse response. 0.53. What is the ratio of the Taxes (in $) of Taxes on exports in 2004 to that in 2008?
Your response must be concise. 0.23. What is the ratio of the Taxes (in $) in Taxes on goods and services in 2004 to that in 2008?
Offer a terse response. 0.55. What is the ratio of the Taxes (in $) in Taxes on income in 2004 to that in 2008?
Offer a terse response. 0.45. What is the ratio of the Taxes (in $) of Taxes on revenue in 2005 to that in 2006?
Provide a succinct answer. 0.9. What is the ratio of the Taxes (in $) of Taxes on exports in 2005 to that in 2006?
Your answer should be very brief. 0.03. What is the ratio of the Taxes (in $) of Taxes on goods and services in 2005 to that in 2006?
Your response must be concise. 0.88. What is the ratio of the Taxes (in $) of Taxes on income in 2005 to that in 2006?
Offer a very short reply. 0.87. What is the ratio of the Taxes (in $) in Taxes on revenue in 2005 to that in 2007?
Your response must be concise. 0.75. What is the ratio of the Taxes (in $) in Taxes on exports in 2005 to that in 2007?
Give a very brief answer. 0.06. What is the ratio of the Taxes (in $) in Taxes on goods and services in 2005 to that in 2007?
Your answer should be very brief. 0.74. What is the ratio of the Taxes (in $) in Taxes on income in 2005 to that in 2007?
Your answer should be very brief. 0.73. What is the ratio of the Taxes (in $) in Taxes on revenue in 2005 to that in 2008?
Provide a succinct answer. 0.61. What is the ratio of the Taxes (in $) in Taxes on exports in 2005 to that in 2008?
Offer a terse response. 0.02. What is the ratio of the Taxes (in $) of Taxes on goods and services in 2005 to that in 2008?
Keep it short and to the point. 0.61. What is the ratio of the Taxes (in $) of Taxes on income in 2005 to that in 2008?
Give a very brief answer. 0.53. What is the ratio of the Taxes (in $) in Taxes on revenue in 2006 to that in 2007?
Provide a succinct answer. 0.84. What is the ratio of the Taxes (in $) of Taxes on exports in 2006 to that in 2007?
Offer a terse response. 2.46. What is the ratio of the Taxes (in $) in Taxes on goods and services in 2006 to that in 2007?
Keep it short and to the point. 0.84. What is the ratio of the Taxes (in $) in Taxes on income in 2006 to that in 2007?
Your answer should be compact. 0.84. What is the ratio of the Taxes (in $) of Taxes on revenue in 2006 to that in 2008?
Provide a succinct answer. 0.68. What is the ratio of the Taxes (in $) of Taxes on exports in 2006 to that in 2008?
Provide a succinct answer. 0.82. What is the ratio of the Taxes (in $) in Taxes on goods and services in 2006 to that in 2008?
Provide a succinct answer. 0.69. What is the ratio of the Taxes (in $) in Taxes on income in 2006 to that in 2008?
Your response must be concise. 0.61. What is the ratio of the Taxes (in $) in Taxes on revenue in 2007 to that in 2008?
Offer a terse response. 0.81. What is the ratio of the Taxes (in $) in Taxes on goods and services in 2007 to that in 2008?
Make the answer very short. 0.83. What is the ratio of the Taxes (in $) of Taxes on income in 2007 to that in 2008?
Your answer should be compact. 0.73. What is the difference between the highest and the second highest Taxes (in $) of Taxes on revenue?
Provide a succinct answer. 3.51e+1. What is the difference between the highest and the second highest Taxes (in $) in Taxes on exports?
Your response must be concise. 5.44e+08. What is the difference between the highest and the second highest Taxes (in $) of Taxes on goods and services?
Your response must be concise. 1.41e+1. What is the difference between the highest and the second highest Taxes (in $) in Taxes on income?
Ensure brevity in your answer.  2.17e+1. What is the difference between the highest and the lowest Taxes (in $) of Taxes on revenue?
Give a very brief answer. 1.01e+11. What is the difference between the highest and the lowest Taxes (in $) in Taxes on exports?
Offer a terse response. 2.94e+09. What is the difference between the highest and the lowest Taxes (in $) of Taxes on goods and services?
Provide a short and direct response. 3.98e+1. What is the difference between the highest and the lowest Taxes (in $) of Taxes on income?
Your answer should be compact. 5.10e+1. 